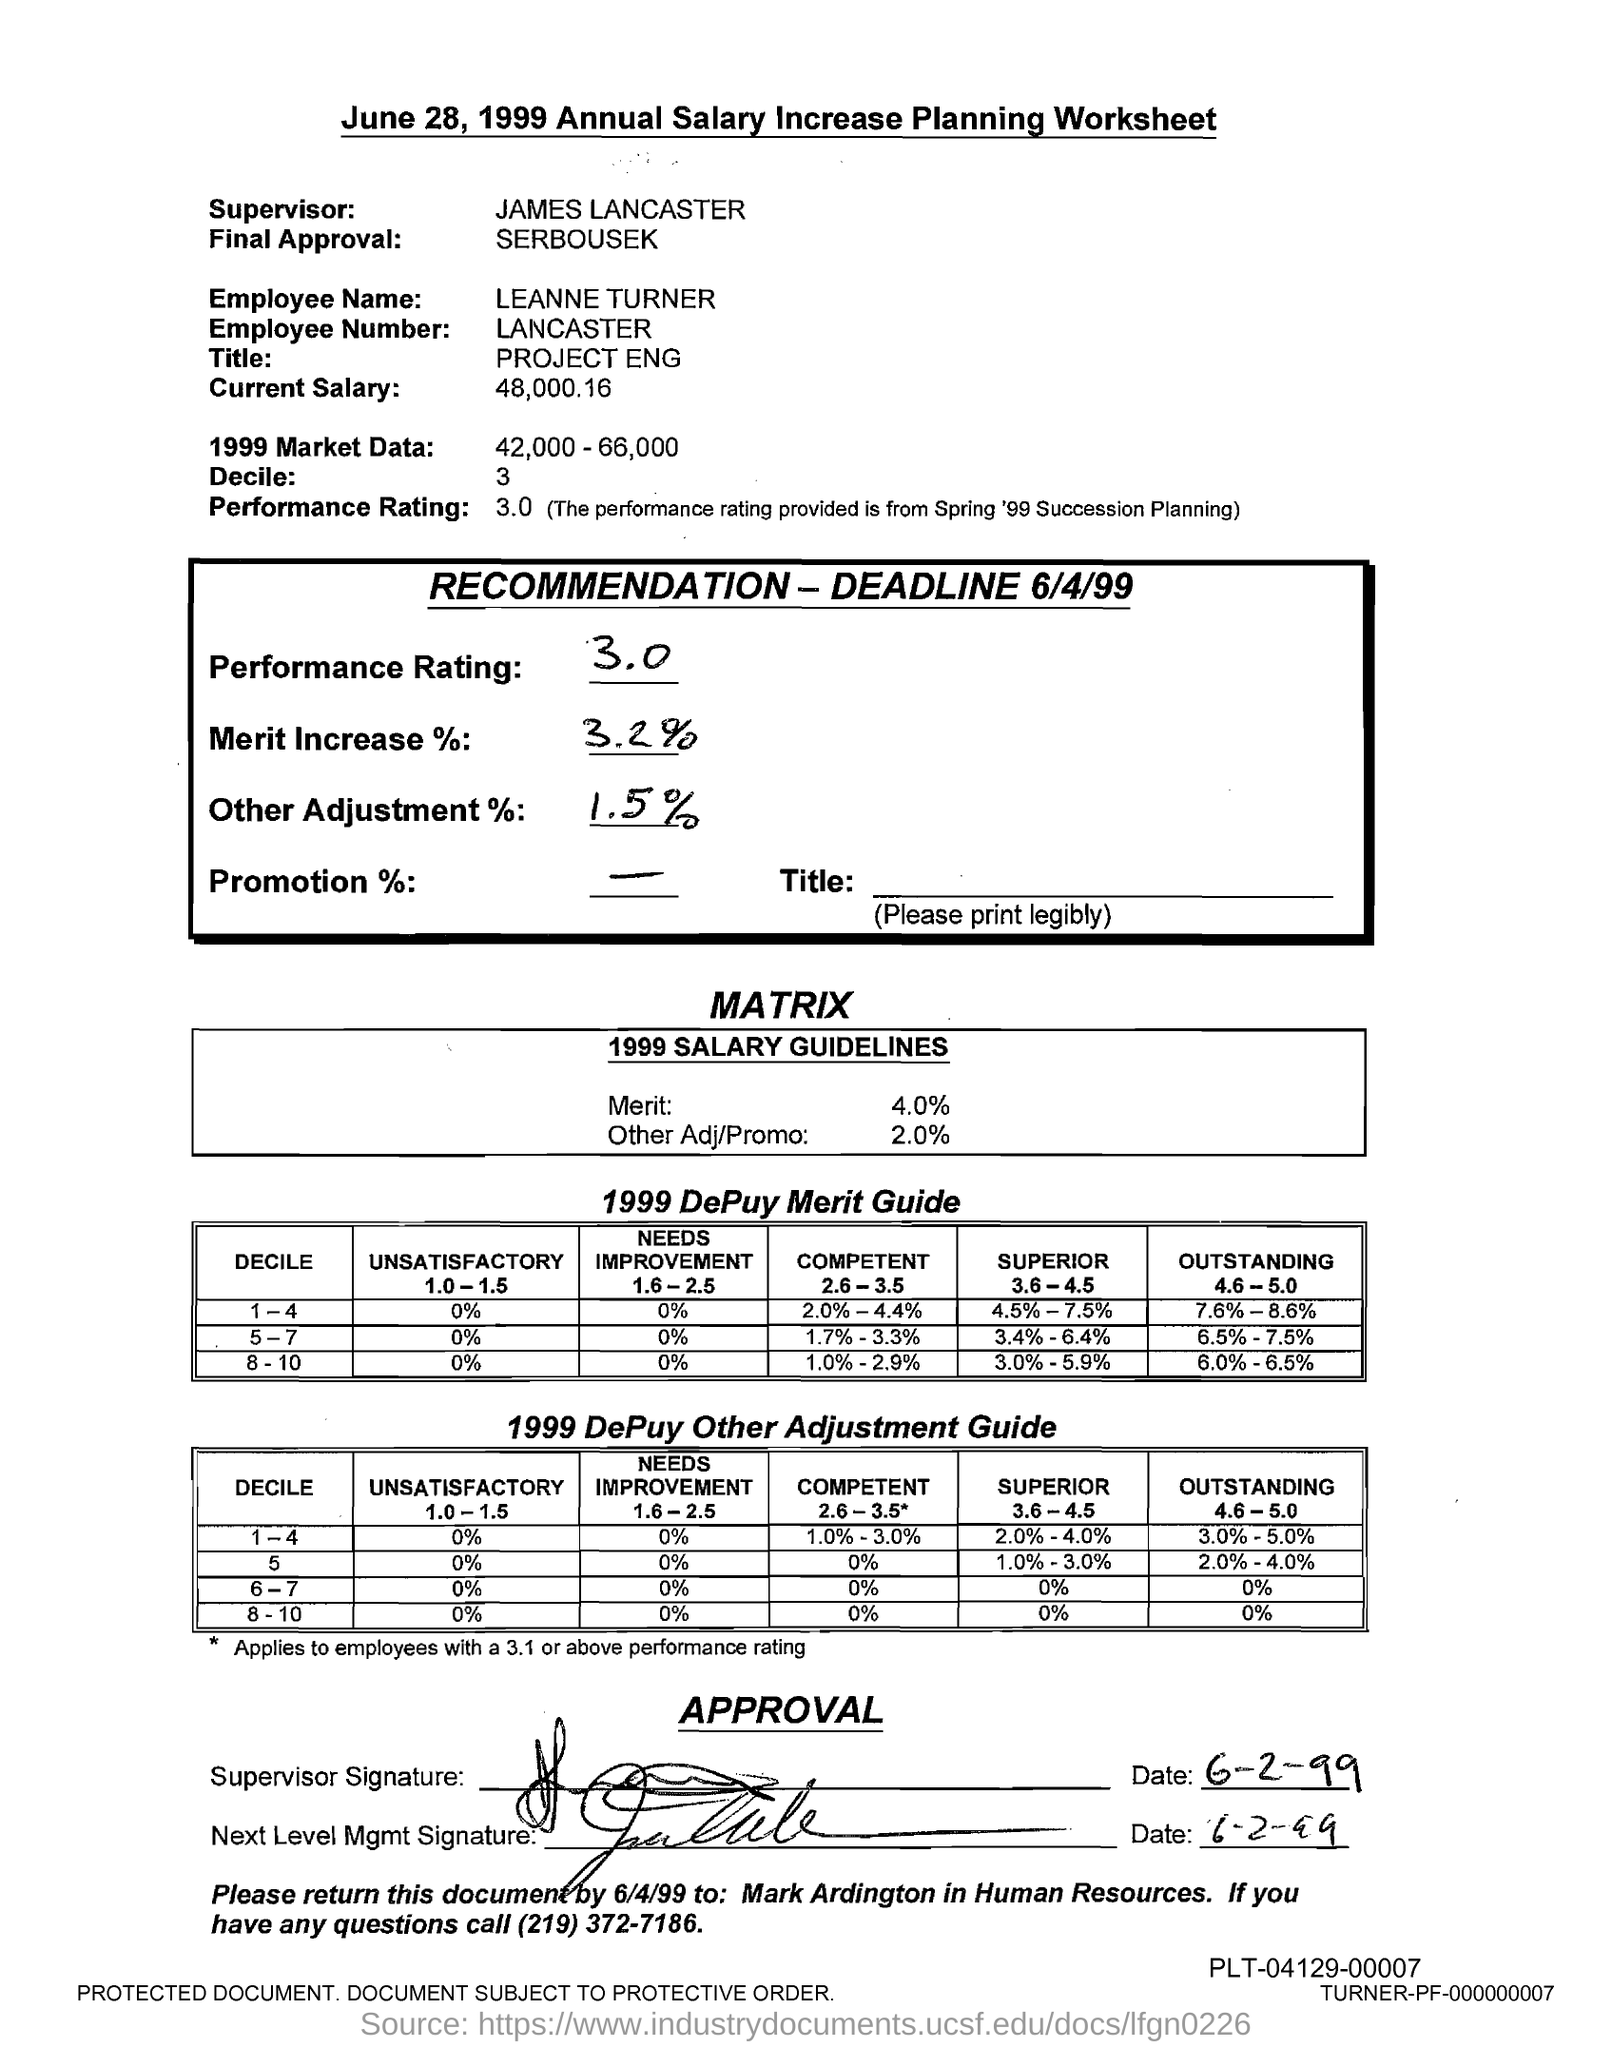Who is the supervisor mentioned in the document?
Ensure brevity in your answer.  James Lancaster. What type of worksheet is this?
Provide a succinct answer. June 28, 1999 Annual Salary Increase Planning Worksheet. What is the employee name given in the document?
Provide a succinct answer. LEANNE TURNER. What is the employee number of LEANNE TURNER?
Ensure brevity in your answer.  LANCASTER. What is the title of LEANNE TURNER?
Your answer should be very brief. PROJECT ENG. What is the current salary of LEANNE TURNER?
Ensure brevity in your answer.  48,000.16. What is the performance rating given in the document?
Offer a very short reply. 3.0. What is the merit increase % given in the document?
Ensure brevity in your answer.  3.2%. What is the signature date mentioned in the document?
Offer a terse response. 6-2-99. 